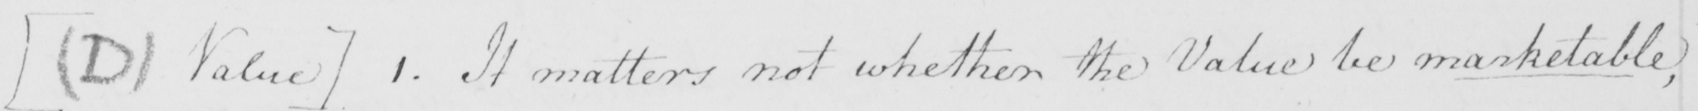What text is written in this handwritten line? [  ( D )  Value ]  1 . It matters not whether the Value be marketable , 